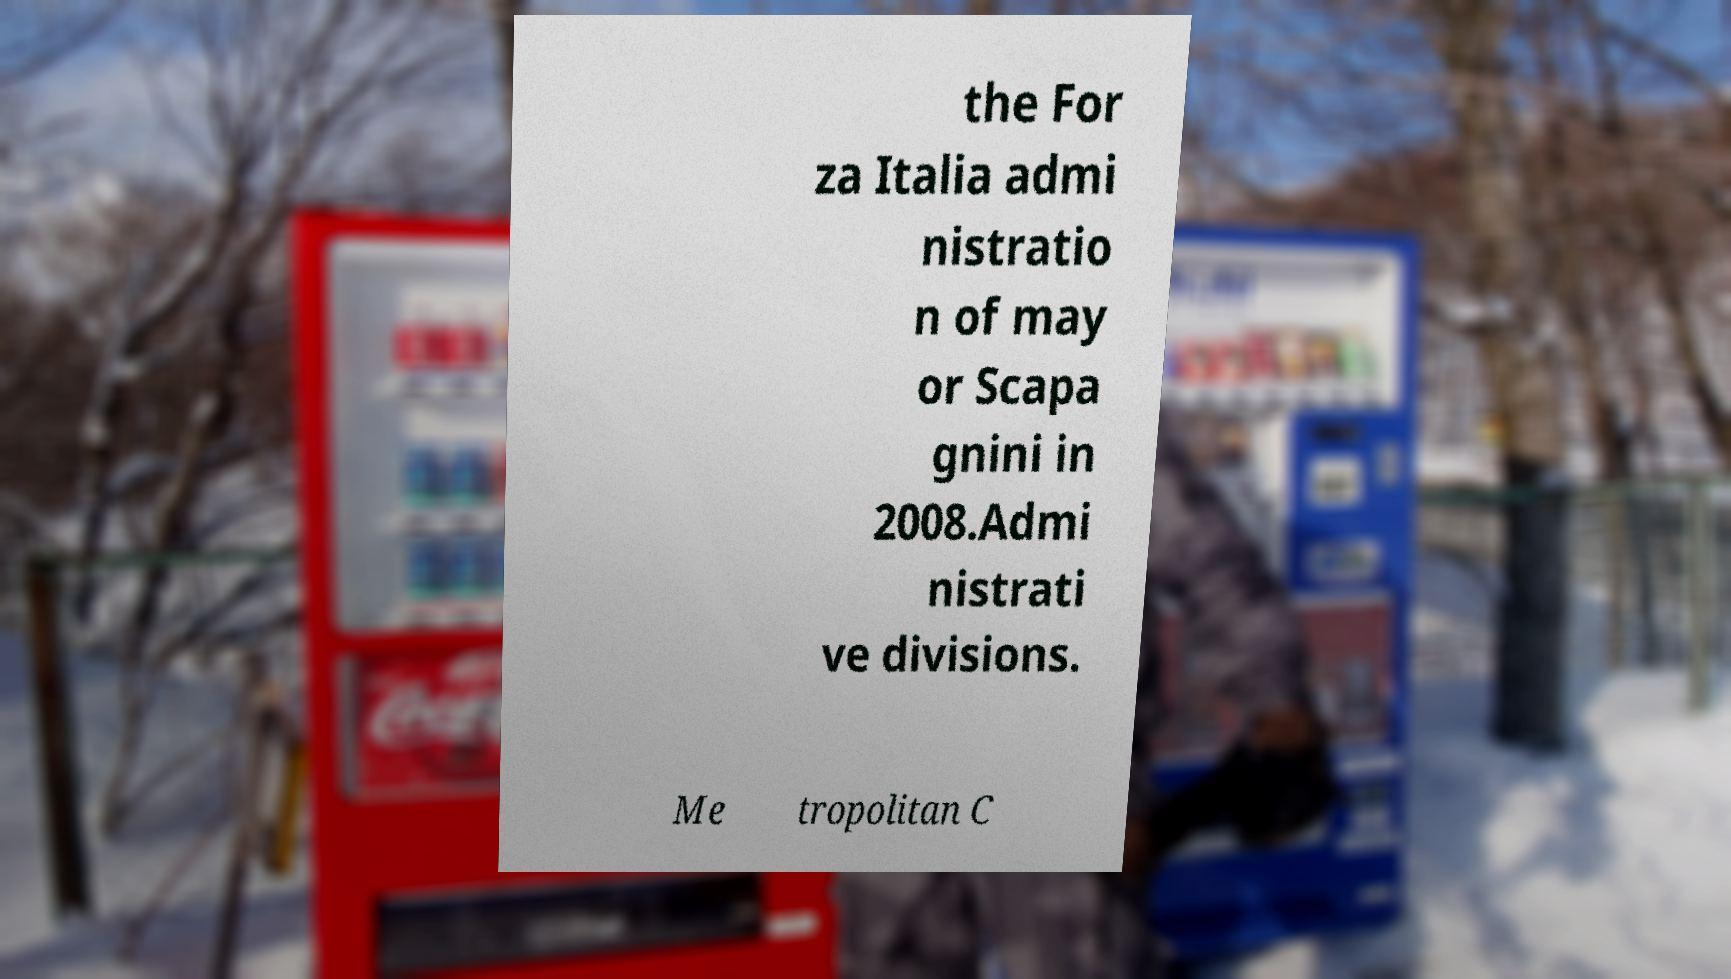Can you read and provide the text displayed in the image?This photo seems to have some interesting text. Can you extract and type it out for me? the For za Italia admi nistratio n of may or Scapa gnini in 2008.Admi nistrati ve divisions. Me tropolitan C 